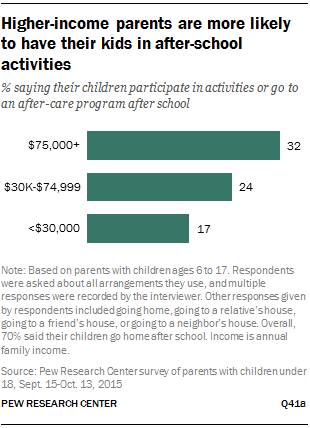Mention a couple of crucial points in this snapshot. The sum of the smallest two bars is greater than the largest bar value. The longest bar in the graph has a value of 32. 